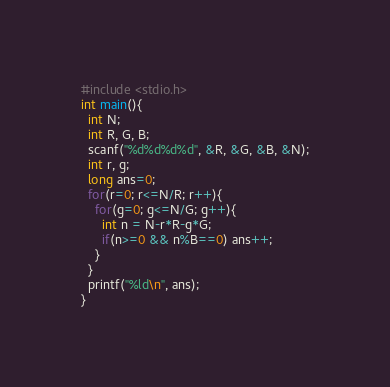<code> <loc_0><loc_0><loc_500><loc_500><_C_>#include <stdio.h>
int main(){
  int N;
  int R, G, B;
  scanf("%d%d%d%d", &R, &G, &B, &N);
  int r, g;
  long ans=0;
  for(r=0; r<=N/R; r++){
    for(g=0; g<=N/G; g++){
      int n = N-r*R-g*G;
      if(n>=0 && n%B==0) ans++;
    }
  }
  printf("%ld\n", ans);
}
</code> 